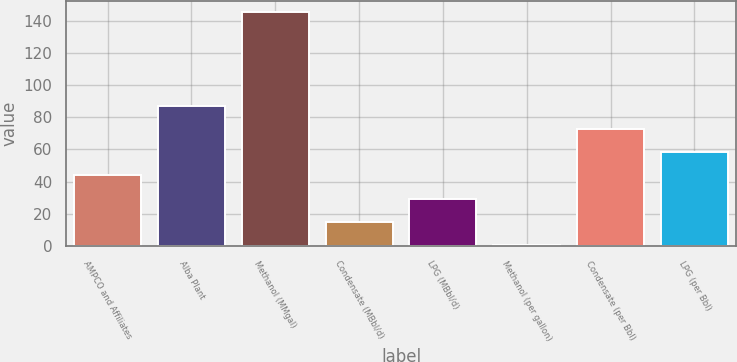Convert chart to OTSL. <chart><loc_0><loc_0><loc_500><loc_500><bar_chart><fcel>AMPCO and Affiliates<fcel>Alba Plant<fcel>Methanol (MMgal)<fcel>Condensate (MBbl/d)<fcel>LPG (MBbl/d)<fcel>Methanol (per gallon)<fcel>Condensate (per Bbl)<fcel>LPG (per Bbl)<nl><fcel>43.92<fcel>87.24<fcel>145<fcel>15.04<fcel>29.48<fcel>0.6<fcel>72.8<fcel>58.36<nl></chart> 